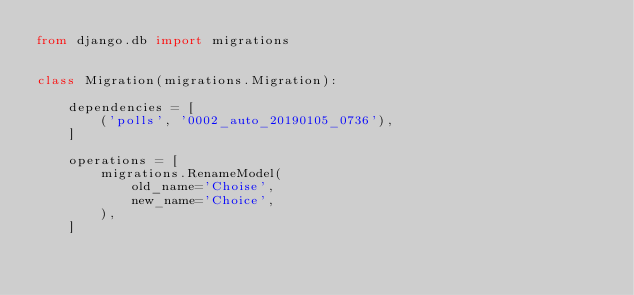<code> <loc_0><loc_0><loc_500><loc_500><_Python_>from django.db import migrations


class Migration(migrations.Migration):

    dependencies = [
        ('polls', '0002_auto_20190105_0736'),
    ]

    operations = [
        migrations.RenameModel(
            old_name='Choise',
            new_name='Choice',
        ),
    ]
</code> 